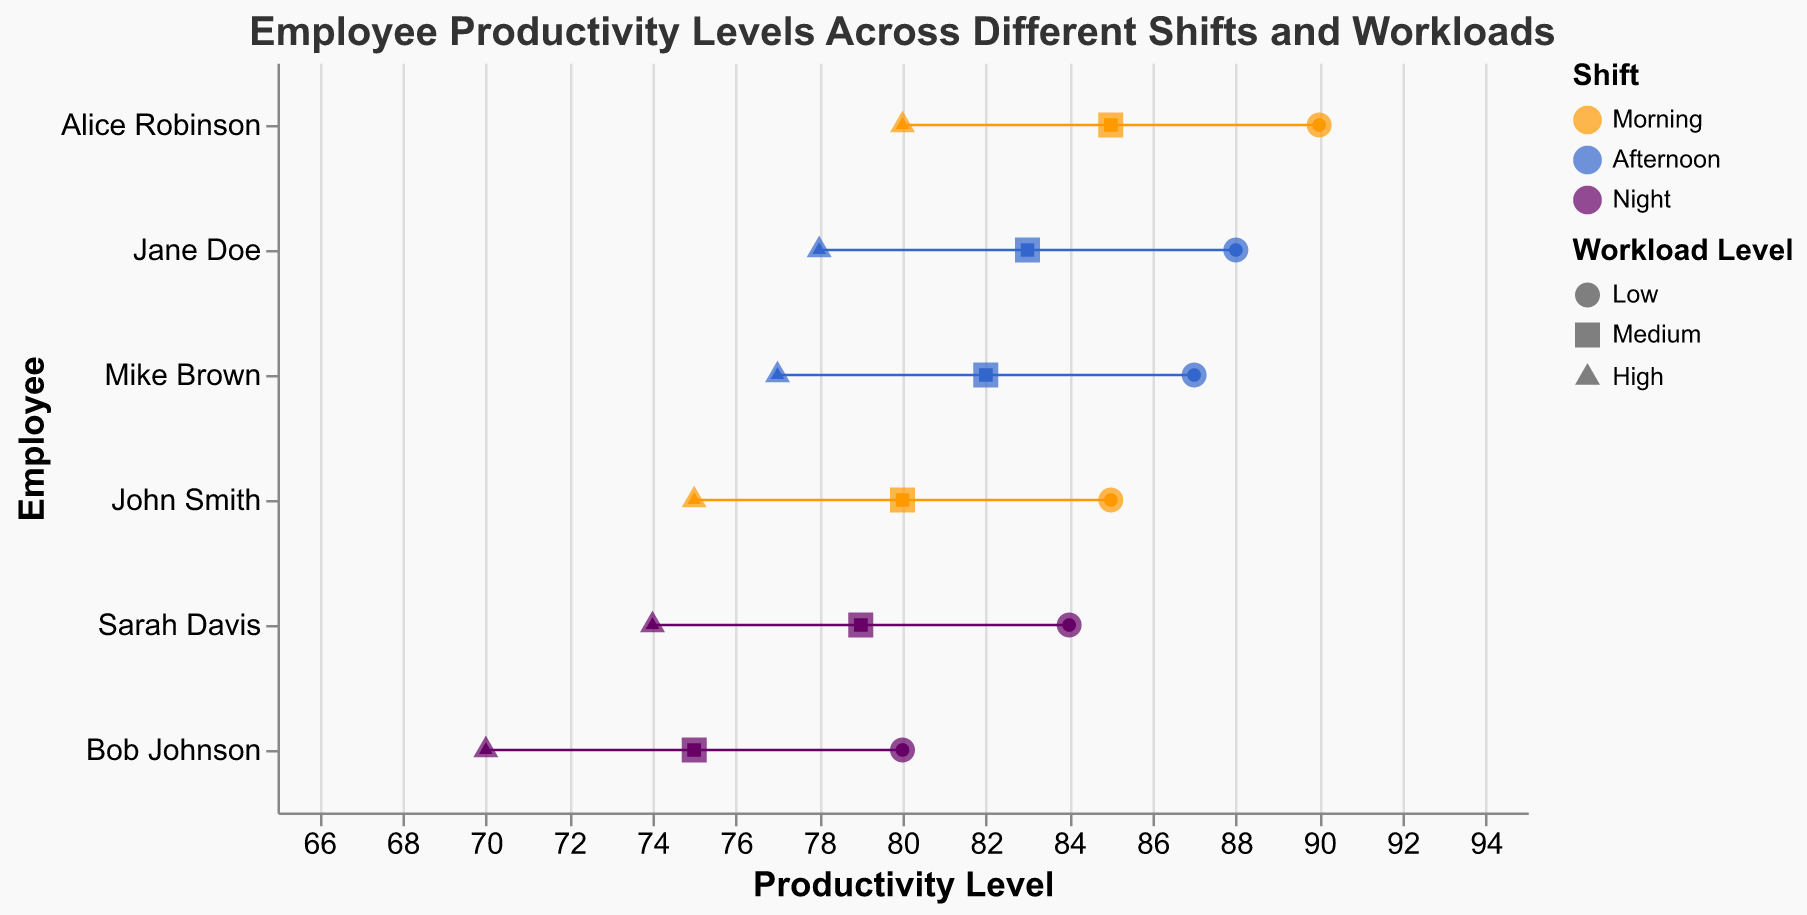What's the title of the figure? The title is usually displayed on top of the figure; for this plot, it is "Employee Productivity Levels Across Different Shifts and Workloads."
Answer: Employee Productivity Levels Across Different Shifts and Workloads How many employees are represented in the plot? Count the distinct names on the y-axis, which represent different employees.
Answer: 6 Which employee has the highest productivity level in the morning shift? Identify the point with the highest x-value (productivity level) among the morning shift data points (which are color-coded). Alice Robinson has a productivity level of 90.
Answer: Alice Robinson Which shift tends to have the highest productivity levels overall? Examine the color-coded data points; morning shift (orange) has consistently higher productivity levels.
Answer: Morning What is the productivity level of Sarah Davis during the night shift with medium workload? Look for the point shaped like a square (medium workload) and colored for the night shift, corresponding to Sarah Davis on the y-axis.
Answer: 79 Who shows the smallest drop in productivity level from low to high workload in the morning shift? Calculate the difference between low and high workload productivity levels for each employee in the morning shift, then find the smallest drop: Alice Robinson (90 to 80, which is a 10-point drop).
Answer: Alice Robinson Among all the employees, who has the lowest productivity level at high workload? Identify the point with the lowest x-value (productivity level) among the data points representing high workload (triangle shape). Bob Johnson has a productivity level of 70.
Answer: Bob Johnson What is the range of productivity levels for Jane Doe in the afternoon shift? For Jane Doe, the productivity levels are 88, 83, and 78. The range is the difference between the maximum and minimum values: 88 - 78 = 10.
Answer: 10 Which employee's productivity levels are consistently higher than 80 for all workload levels? Identify employees whose productivity levels (across all workloads) are all above 80. Alice Robinson's levels are 90, 85, and 80.
Answer: Alice Robinson How does the productivity level of Mike Brown in the afternoon shift with high workload compare to Bob Johnson in the night shift with high workload? Compare the x-values (productivity levels) of the relevant points: Mike Brown has 77, and Bob Johnson has 70. Mike Brown's level is higher.
Answer: Mike Brown's is higher 